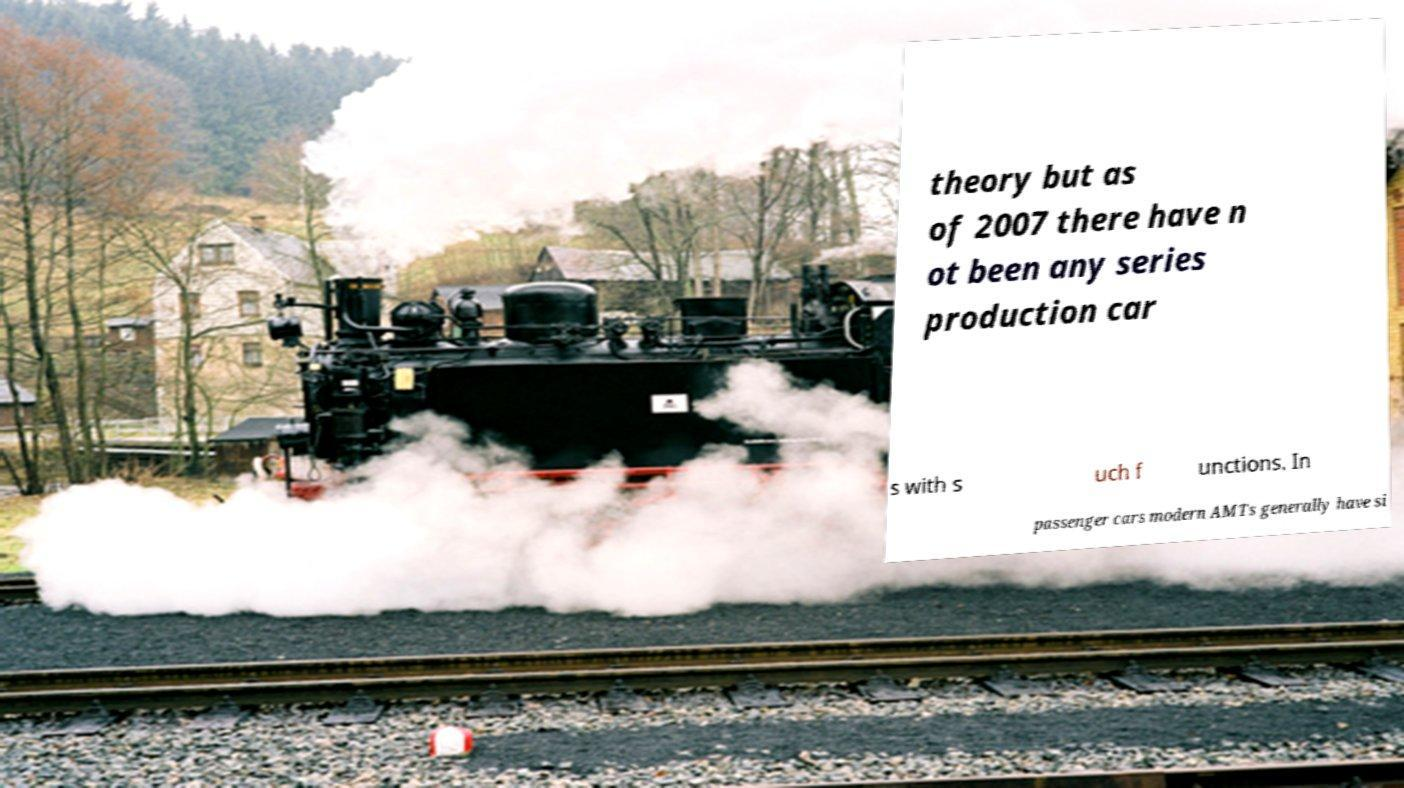Could you extract and type out the text from this image? theory but as of 2007 there have n ot been any series production car s with s uch f unctions. In passenger cars modern AMTs generally have si 